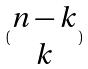<formula> <loc_0><loc_0><loc_500><loc_500>( \begin{matrix} n - k \\ k \end{matrix} )</formula> 